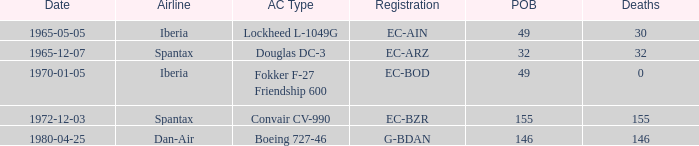What is the number of people on board at Iberia Airline, with the aircraft type of lockheed l-1049g? 49.0. 